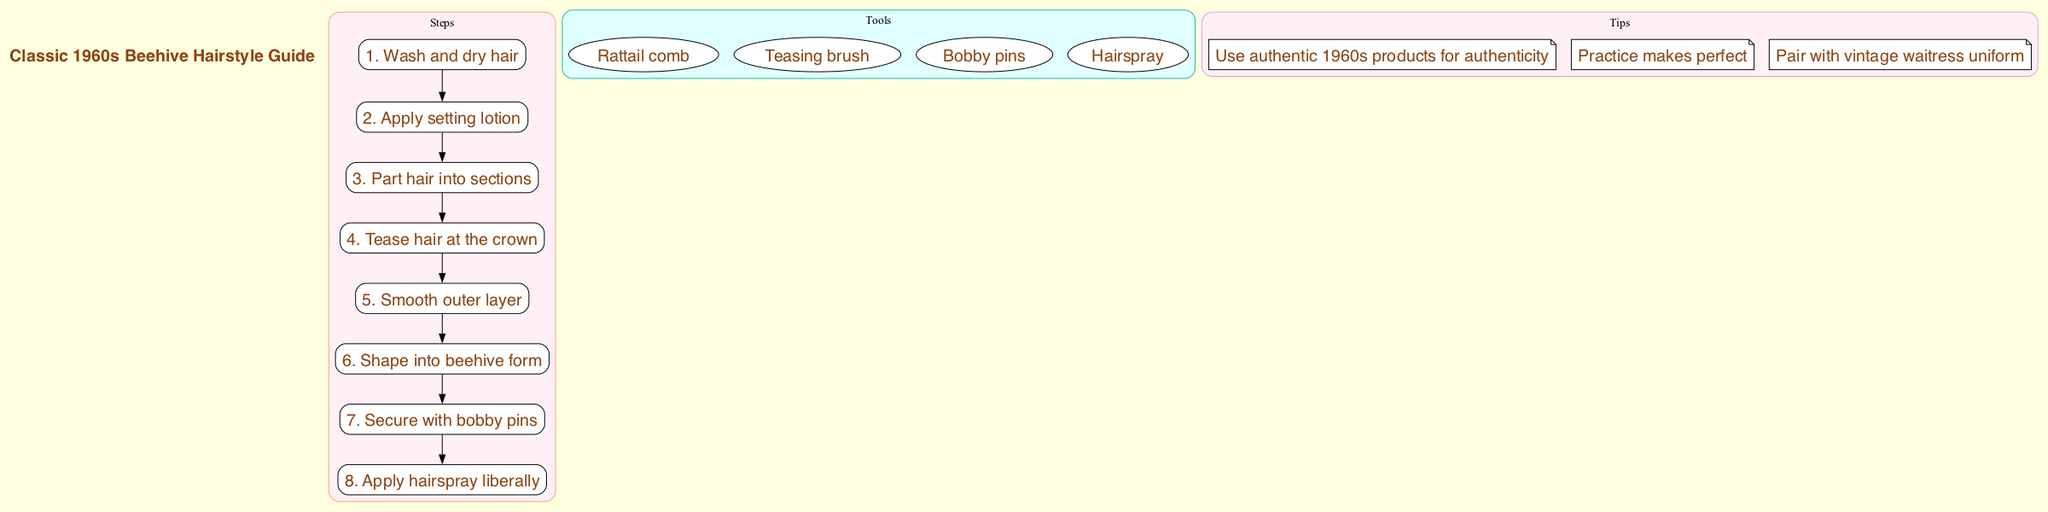What is the first step in creating a classic beehive hairstyle? The first step listed in the diagram is "Wash and dry hair." This is clearly labeled as step 1, indicating the starting point of the process.
Answer: Wash and dry hair How many total steps are there in the beehive hairstyle guide? By counting each labeled step in the diagram, we find that there are eight steps in total listed under the "Steps" cluster.
Answer: 8 What tool is used to tease hair? The diagram explicitly lists "Teasing brush" as one of the tools needed for creating the hairstyle, which is responsible for teasing the hair.
Answer: Teasing brush What is the last step in the beehive hairstyle process? The diagram communicates that the last step is "Apply hairspray liberally," which is step 8, indicating the final action in the hairstyling process.
Answer: Apply hairspray liberally Which cluster contains tips for creating the beehive hairstyle? The tips for creating the hairstyle are listed under a specially marked cluster titled "Tips," indicating where this information is located in the diagram.
Answer: Tips What do you apply after parting hair into sections? According to the steps listed, after parting the hair into sections (step 3), the next action is to "Tease hair at the crown," establishing the direct sequence of processes.
Answer: Tease hair at the crown What color is used in the cluster that contains the steps? The cluster labeled "Steps" is filled with the color "#FFA07A," which can be identified through the diagram's color coding for different sections.
Answer: #FFA07A How many tips are provided in the diagram? The tips section features three distinct tips, which can be confirmed by counting the individual entries under the "Tips" cluster in the diagram.
Answer: 3 